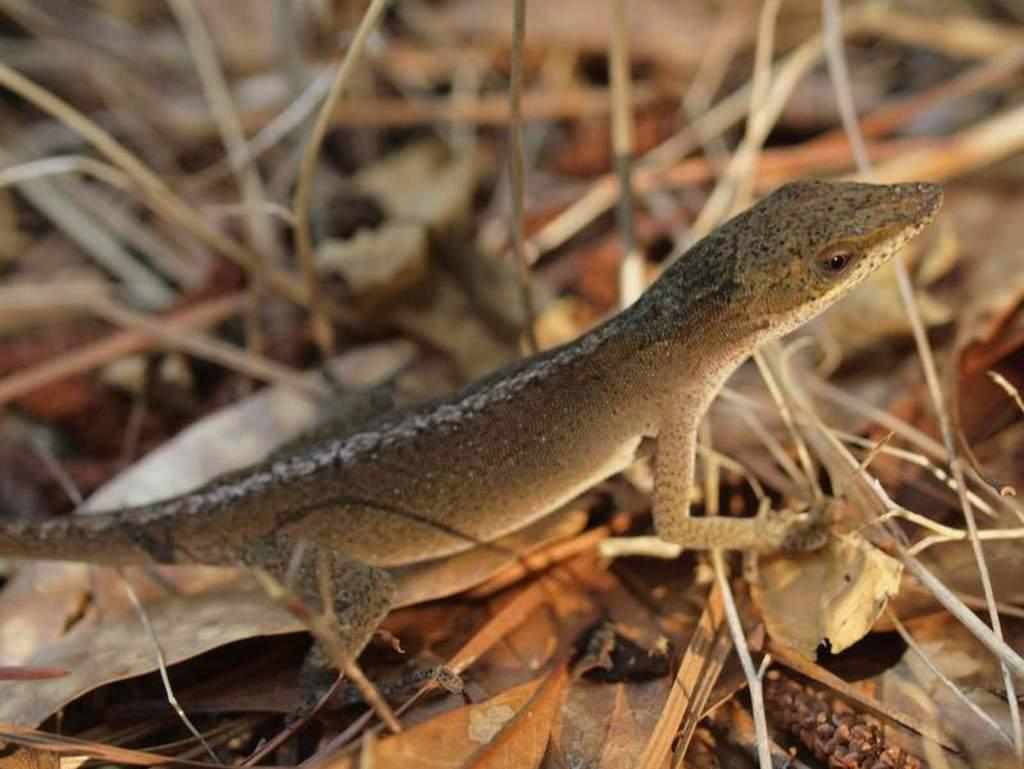What type of animal is present in the image? There is an animal in the image, but its specific type cannot be determined from the provided facts. What is the animal situated on in the image? The animal is on dried sticks and leaves. Can you describe the background of the image? The background of the image is blurred. What type of chain is the animal wearing in the image? There is no chain visible in the image; the animal is situated on dried sticks and leaves. How many horses are present in the image? There are no horses present in the image; it features an animal on dried sticks and leaves. 